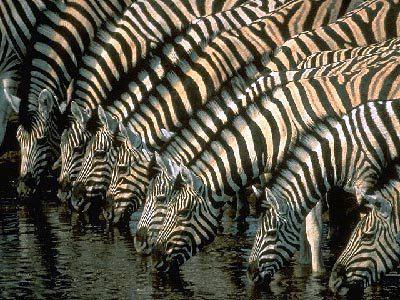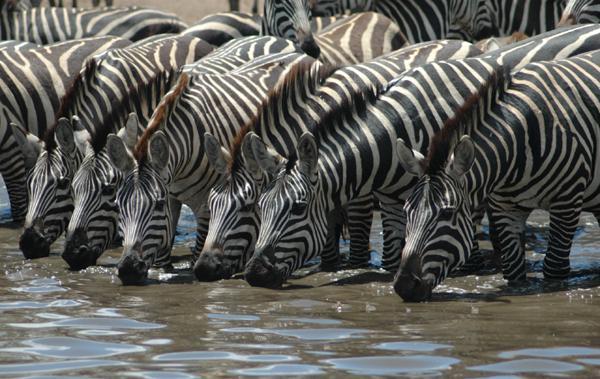The first image is the image on the left, the second image is the image on the right. Evaluate the accuracy of this statement regarding the images: "One image shows at least 8 zebras lined up close together to drink, and the other image shows a zebra and a different type of animal near a pool of water.". Is it true? Answer yes or no. No. The first image is the image on the left, the second image is the image on the right. Analyze the images presented: Is the assertion "The left image contains no more than three zebras." valid? Answer yes or no. No. 